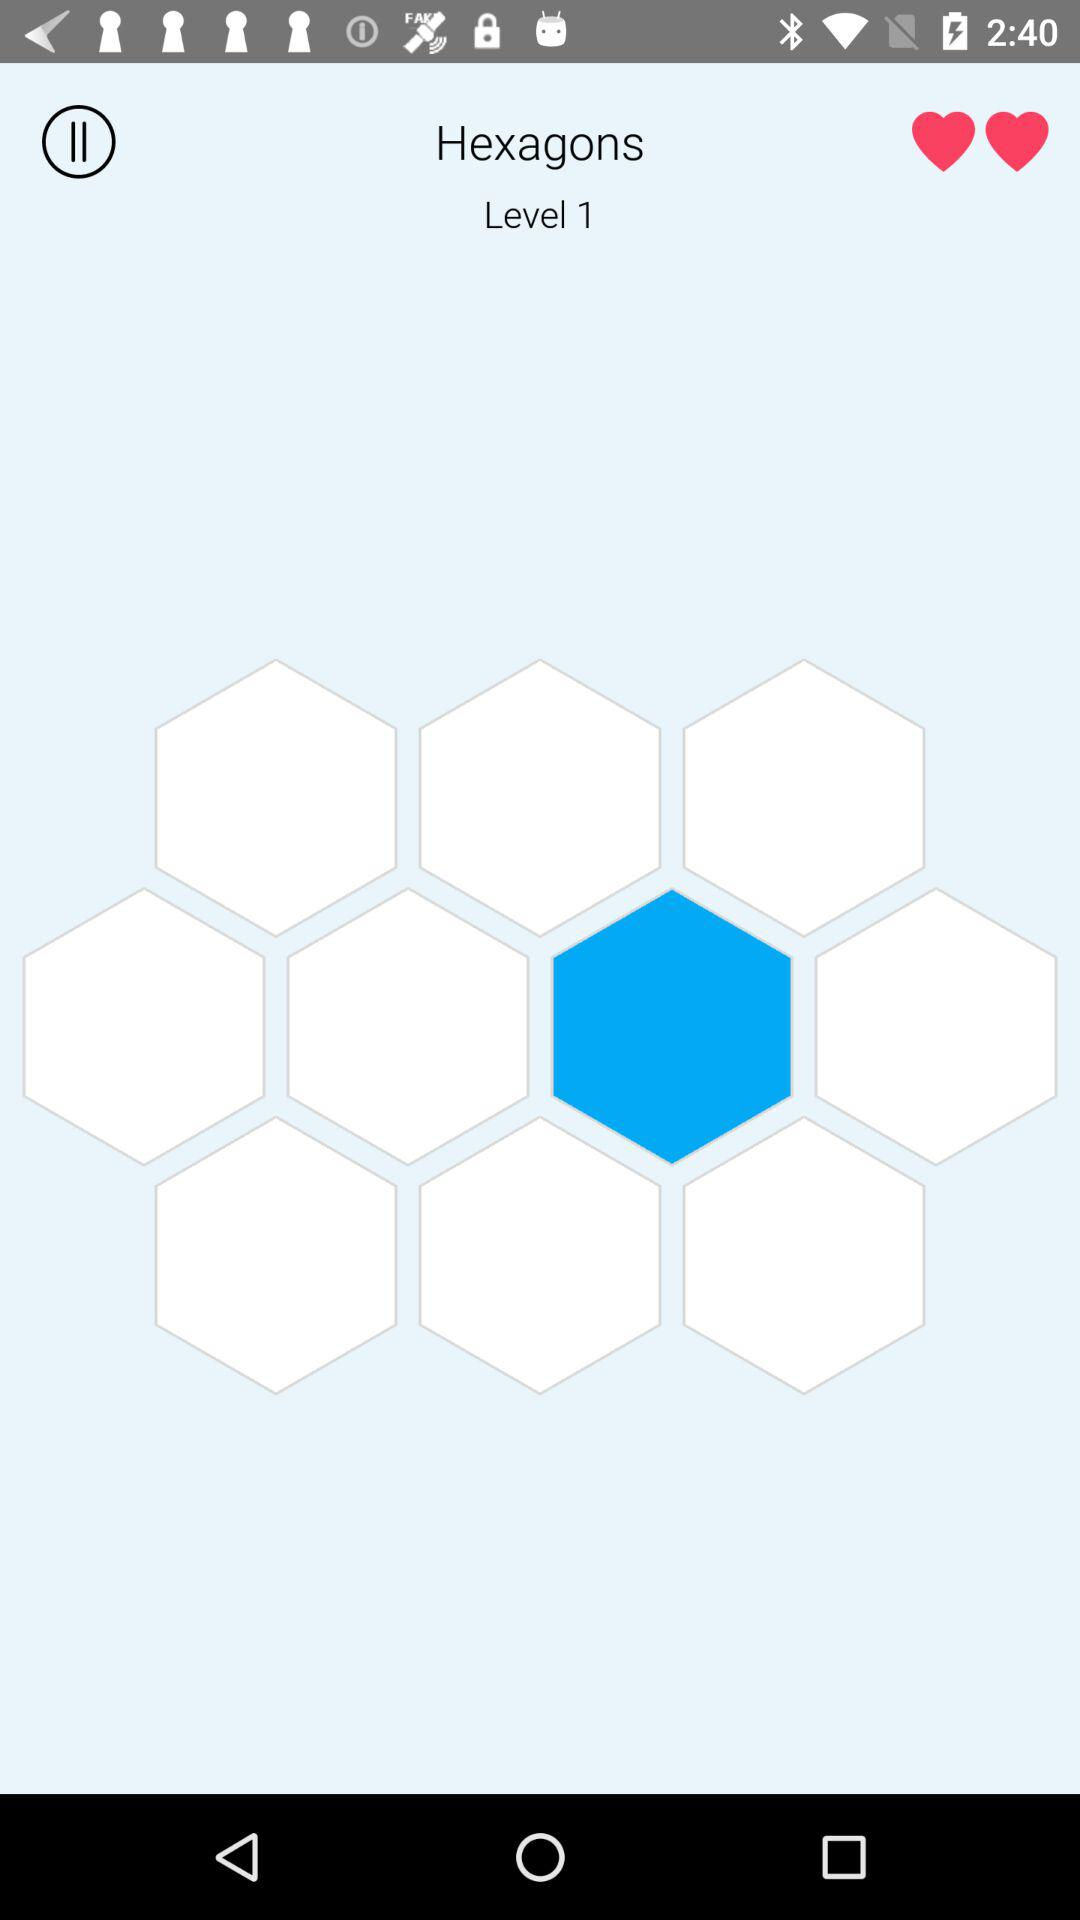What level is this? This is level 1. 